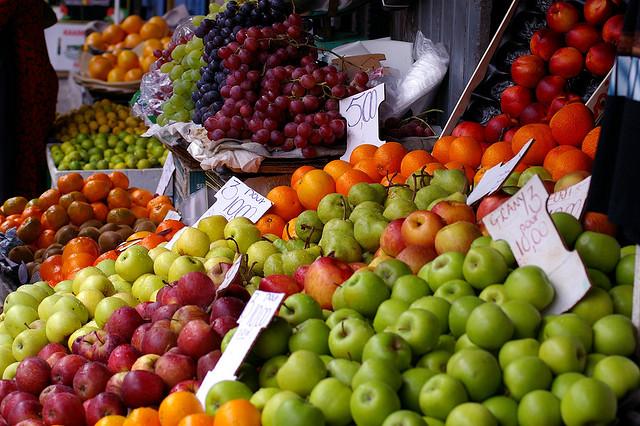Are there any Gala apples?
Concise answer only. Yes. What is being sold?
Quick response, please. Fruit. What fruit is closest to the camera?
Answer briefly. Apples. How many colors of apples are there?
Quick response, please. 3. Where are the apples resting?
Give a very brief answer. On other apples. What do the signs on the apples indicate?
Keep it brief. Price. 